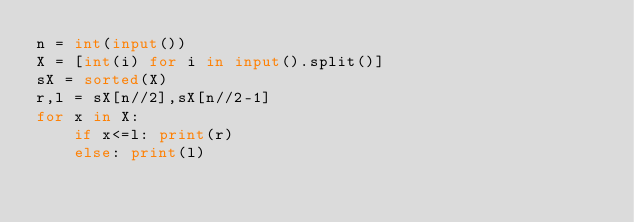Convert code to text. <code><loc_0><loc_0><loc_500><loc_500><_Python_>n = int(input())
X = [int(i) for i in input().split()]
sX = sorted(X)
r,l = sX[n//2],sX[n//2-1]
for x in X:
    if x<=l: print(r)
    else: print(l)
</code> 